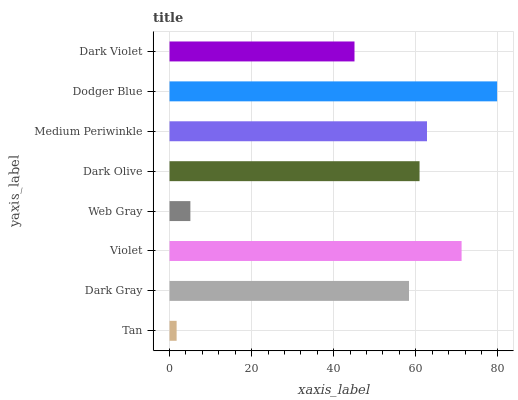Is Tan the minimum?
Answer yes or no. Yes. Is Dodger Blue the maximum?
Answer yes or no. Yes. Is Dark Gray the minimum?
Answer yes or no. No. Is Dark Gray the maximum?
Answer yes or no. No. Is Dark Gray greater than Tan?
Answer yes or no. Yes. Is Tan less than Dark Gray?
Answer yes or no. Yes. Is Tan greater than Dark Gray?
Answer yes or no. No. Is Dark Gray less than Tan?
Answer yes or no. No. Is Dark Olive the high median?
Answer yes or no. Yes. Is Dark Gray the low median?
Answer yes or no. Yes. Is Dodger Blue the high median?
Answer yes or no. No. Is Web Gray the low median?
Answer yes or no. No. 